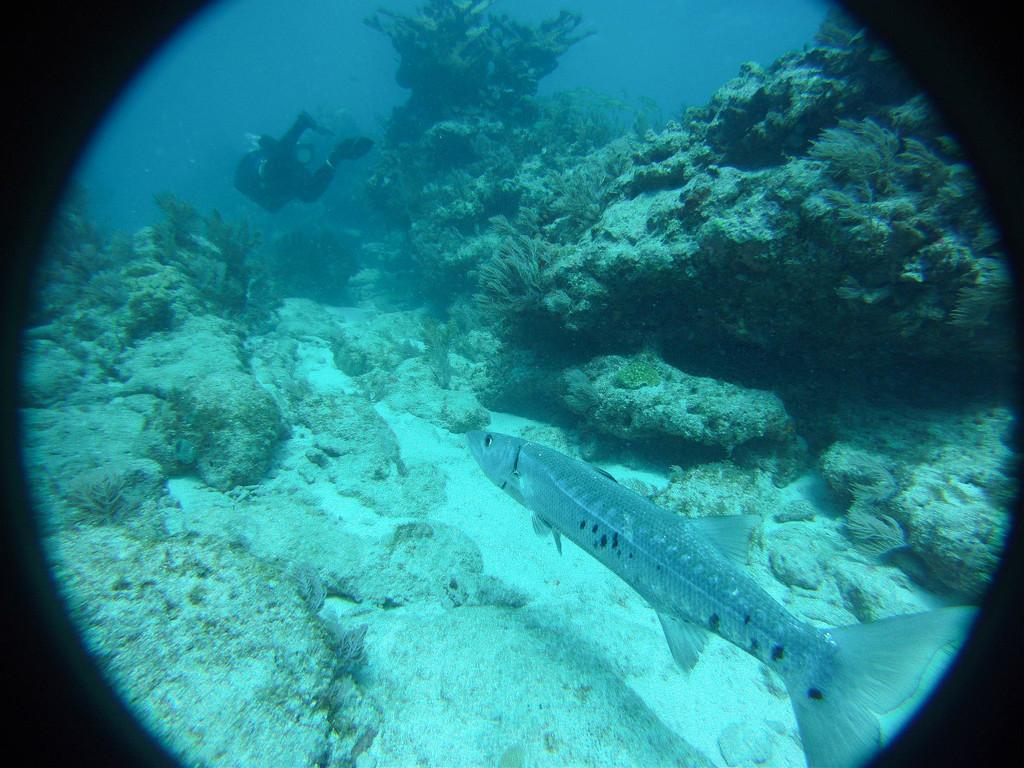What type of animals can be seen in the image? There are fish in the image. What is the person in the image doing? There is a person in the water. What other elements can be seen in the image besides the fish and person? There are plants and rocks visible in the image. What type of hydrant is present in the image? There is no hydrant present in the image. How does the lawyer interact with the fish in the image? There is no lawyer present in the image, so it is not possible to determine how they might interact with the fish. 